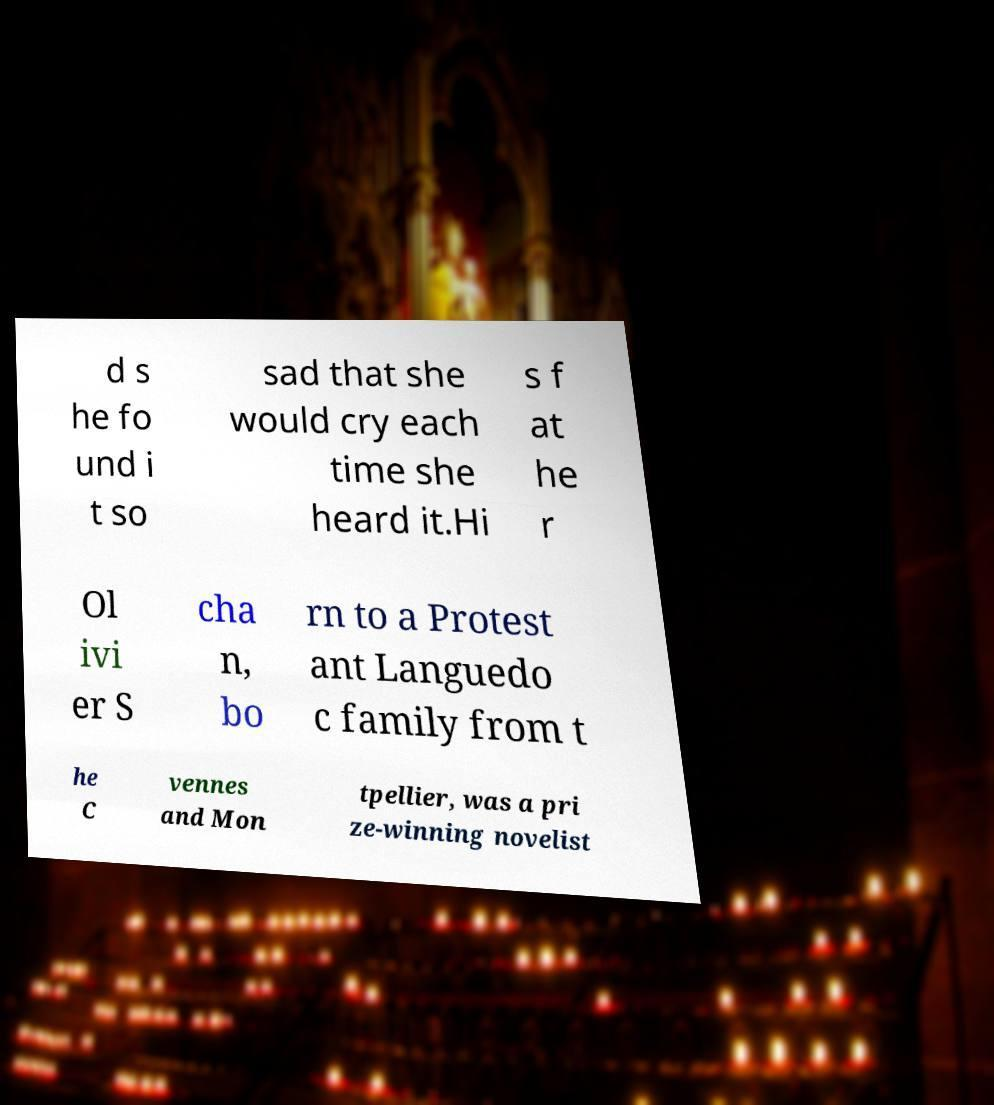Can you accurately transcribe the text from the provided image for me? d s he fo und i t so sad that she would cry each time she heard it.Hi s f at he r Ol ivi er S cha n, bo rn to a Protest ant Languedo c family from t he C vennes and Mon tpellier, was a pri ze-winning novelist 